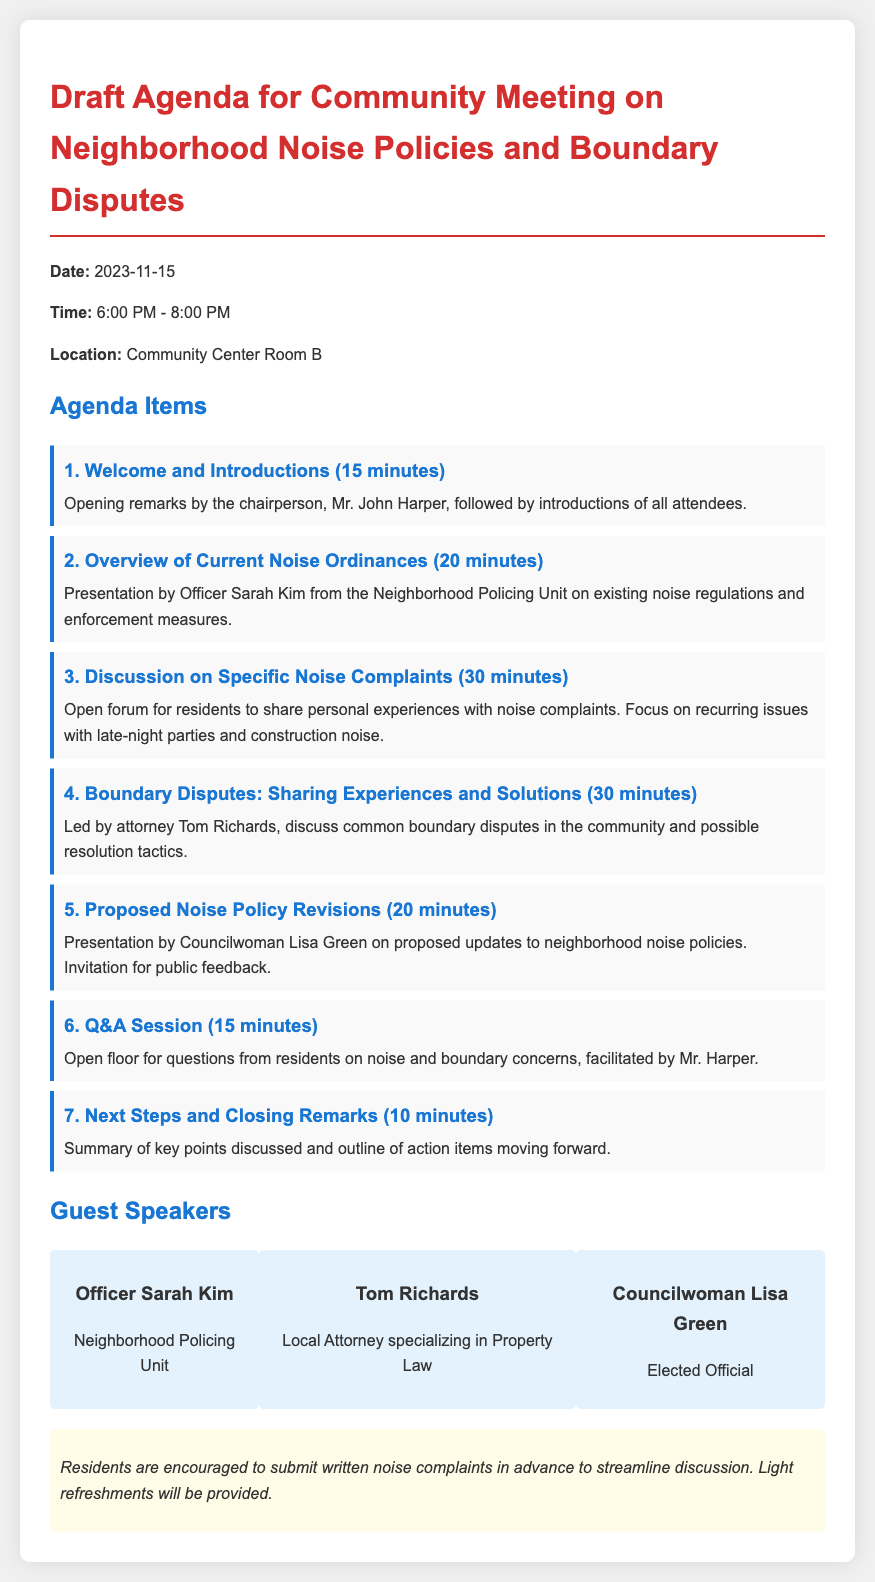What is the date of the community meeting? The date of the community meeting is specifically mentioned in the document.
Answer: 2023-11-15 Who is the chairperson for the meeting? The document provides the name of the person leading the meeting.
Answer: Mr. John Harper How long is the discussion on specific noise complaints scheduled? The document states the duration allocated for this discussion.
Answer: 30 minutes What is the title of the presentation by Officer Sarah Kim? The document describes the content of Officer Sarah Kim's presentation.
Answer: Overview of Current Noise Ordinances Which speaker specializes in property law? The document identifies the speaker with expertise in property law.
Answer: Tom Richards What time does the meeting start? The starting time of the meeting is clearly indicated in the document.
Answer: 6:00 PM What is the total duration of the meeting? The start and end times of the meeting allow us to compute the total duration.
Answer: 2 hours What is encouraged before the meeting? The document suggests an action that residents should take prior to the meeting for better discussion.
Answer: Submit written noise complaints in advance 